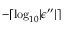Convert formula to latex. <formula><loc_0><loc_0><loc_500><loc_500>- \lceil \log _ { 1 0 } | \epsilon ^ { \prime \prime } | \rceil</formula> 